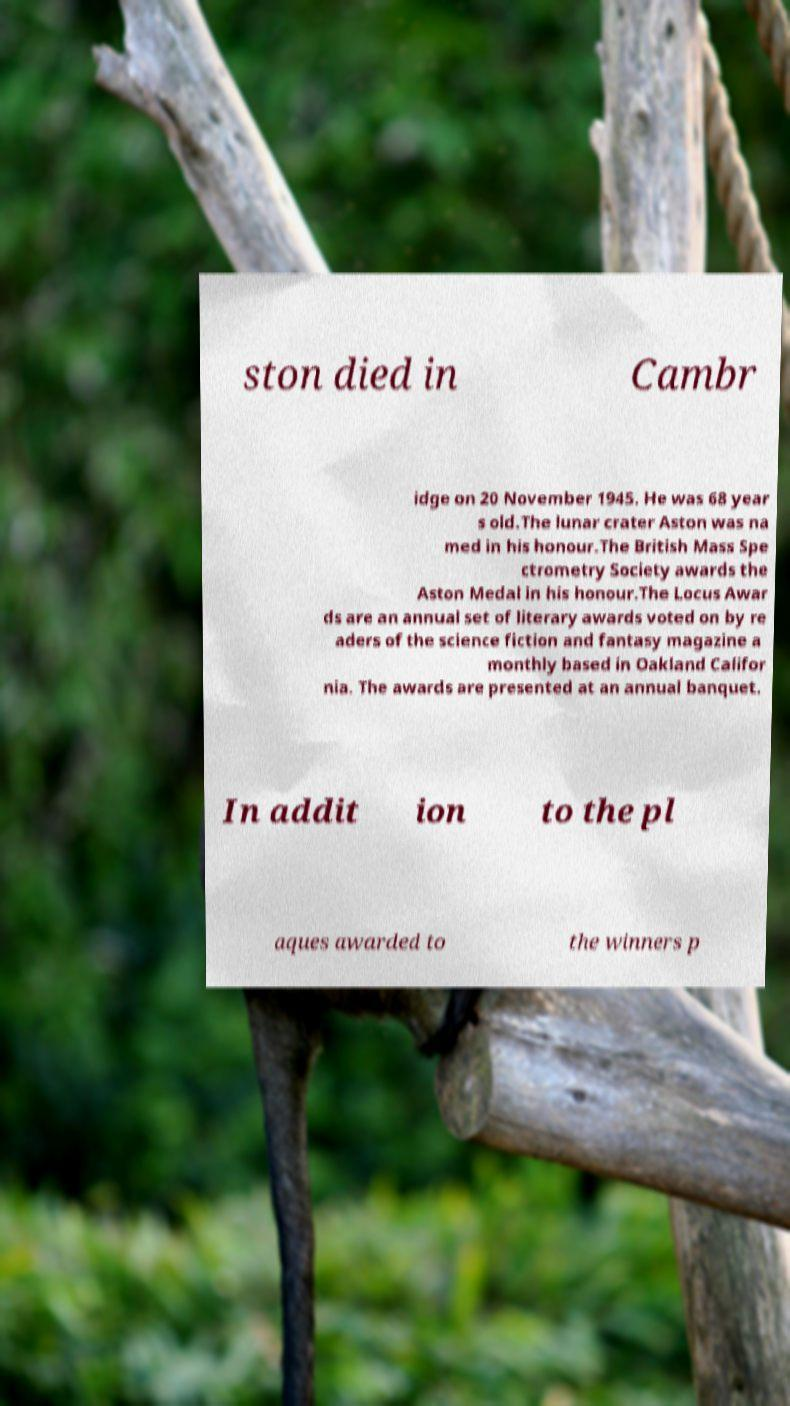For documentation purposes, I need the text within this image transcribed. Could you provide that? ston died in Cambr idge on 20 November 1945. He was 68 year s old.The lunar crater Aston was na med in his honour.The British Mass Spe ctrometry Society awards the Aston Medal in his honour.The Locus Awar ds are an annual set of literary awards voted on by re aders of the science fiction and fantasy magazine a monthly based in Oakland Califor nia. The awards are presented at an annual banquet. In addit ion to the pl aques awarded to the winners p 